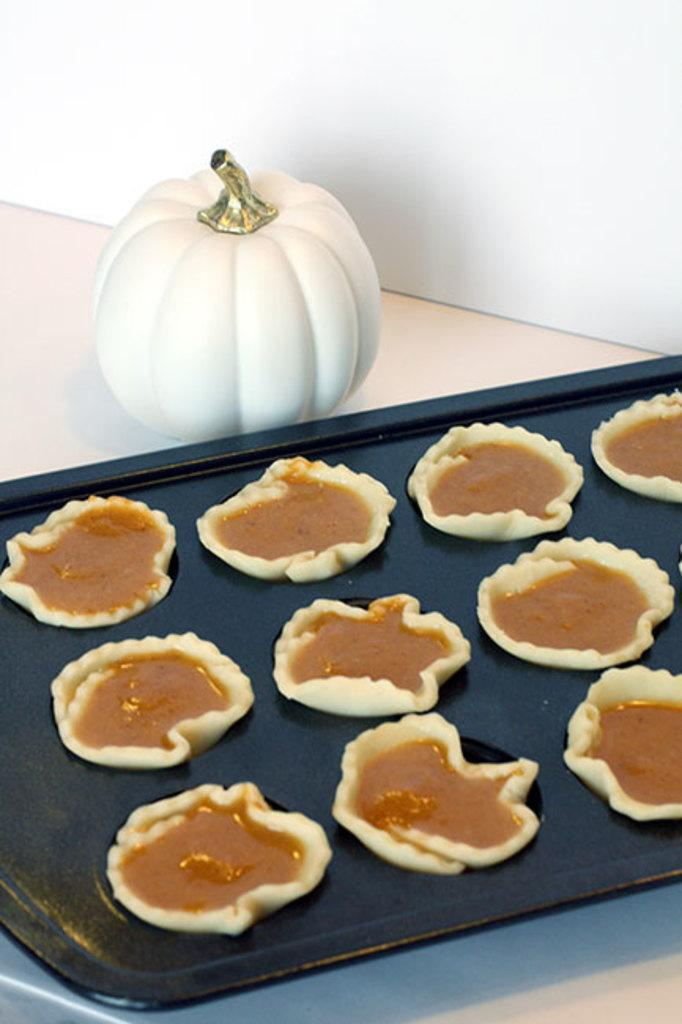What piece of furniture can be seen in the image? There is a table in the image. What is placed on the table? There is a plate present on the table. What is on the plate? Food items are on the plate. How many wings are visible on the field in the image? There is no field or wings present in the image; it only features a table with a plate and food items. 